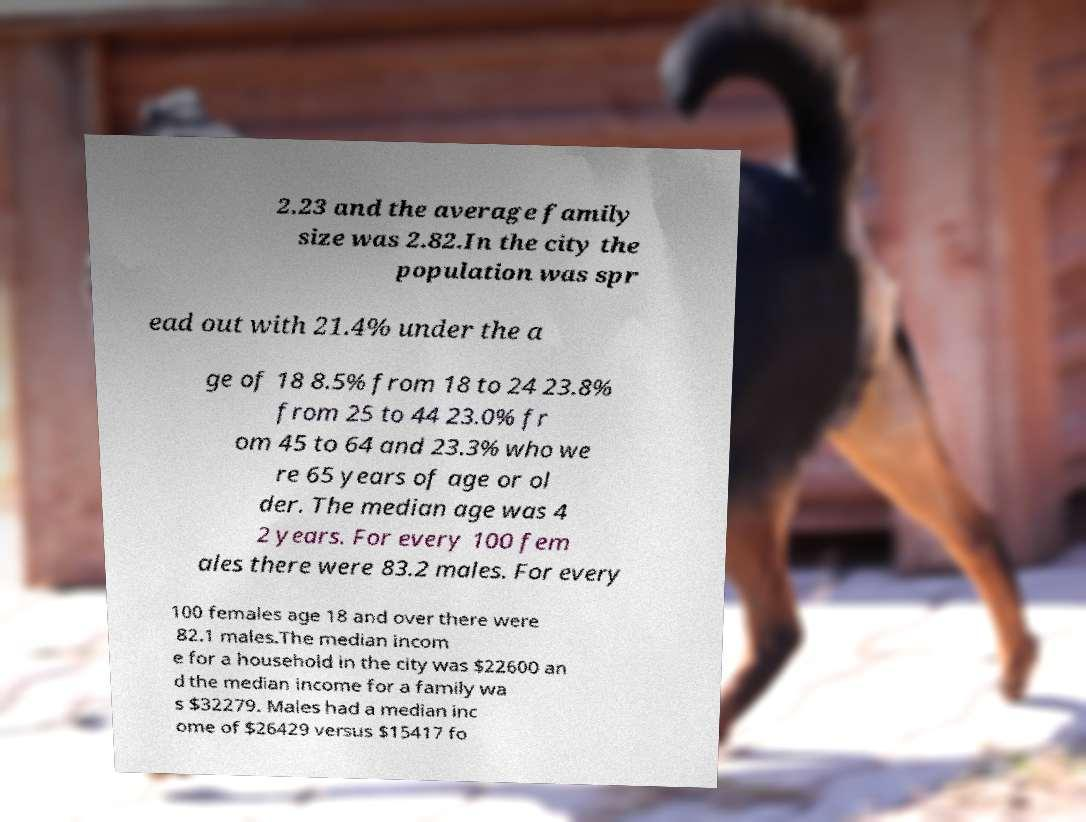Could you assist in decoding the text presented in this image and type it out clearly? 2.23 and the average family size was 2.82.In the city the population was spr ead out with 21.4% under the a ge of 18 8.5% from 18 to 24 23.8% from 25 to 44 23.0% fr om 45 to 64 and 23.3% who we re 65 years of age or ol der. The median age was 4 2 years. For every 100 fem ales there were 83.2 males. For every 100 females age 18 and over there were 82.1 males.The median incom e for a household in the city was $22600 an d the median income for a family wa s $32279. Males had a median inc ome of $26429 versus $15417 fo 